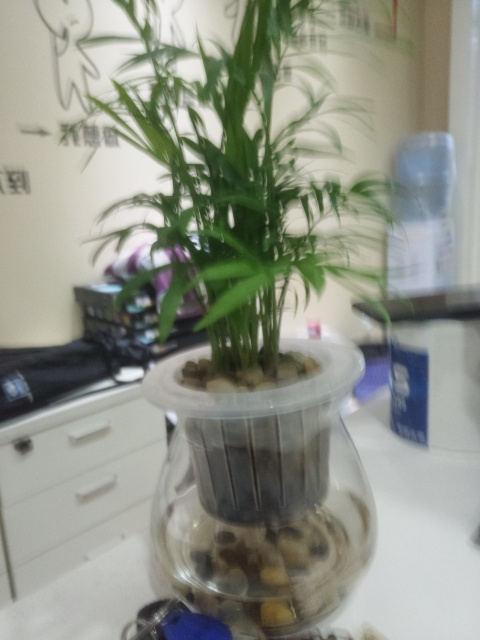Does the subject lack all texture details? While the subject of the image, which appears to be a plant, does have texture details, the photograph is blurred, making it challenging to discern all of these details clearly. 